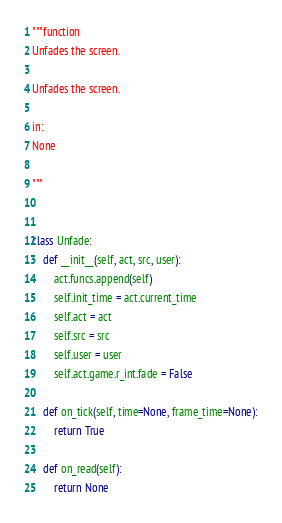Convert code to text. <code><loc_0><loc_0><loc_500><loc_500><_Python_>"""function
Unfades the screen.

Unfades the screen.

in:
None

"""


class Unfade:
    def __init__(self, act, src, user):
        act.funcs.append(self)
        self.init_time = act.current_time
        self.act = act
        self.src = src
        self.user = user
        self.act.game.r_int.fade = False

    def on_tick(self, time=None, frame_time=None):
        return True

    def on_read(self):
        return None
</code> 